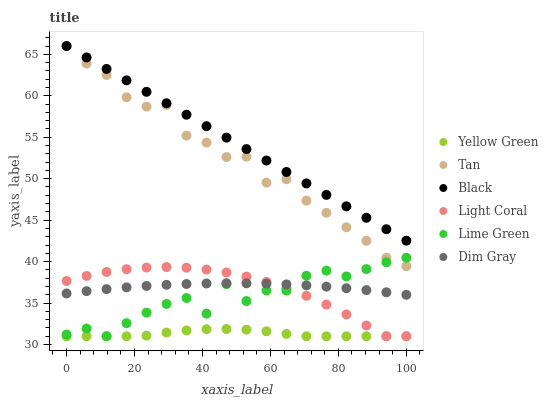Does Yellow Green have the minimum area under the curve?
Answer yes or no. Yes. Does Black have the maximum area under the curve?
Answer yes or no. Yes. Does Light Coral have the minimum area under the curve?
Answer yes or no. No. Does Light Coral have the maximum area under the curve?
Answer yes or no. No. Is Black the smoothest?
Answer yes or no. Yes. Is Lime Green the roughest?
Answer yes or no. Yes. Is Yellow Green the smoothest?
Answer yes or no. No. Is Yellow Green the roughest?
Answer yes or no. No. Does Yellow Green have the lowest value?
Answer yes or no. Yes. Does Black have the lowest value?
Answer yes or no. No. Does Tan have the highest value?
Answer yes or no. Yes. Does Light Coral have the highest value?
Answer yes or no. No. Is Dim Gray less than Tan?
Answer yes or no. Yes. Is Black greater than Yellow Green?
Answer yes or no. Yes. Does Yellow Green intersect Lime Green?
Answer yes or no. Yes. Is Yellow Green less than Lime Green?
Answer yes or no. No. Is Yellow Green greater than Lime Green?
Answer yes or no. No. Does Dim Gray intersect Tan?
Answer yes or no. No. 